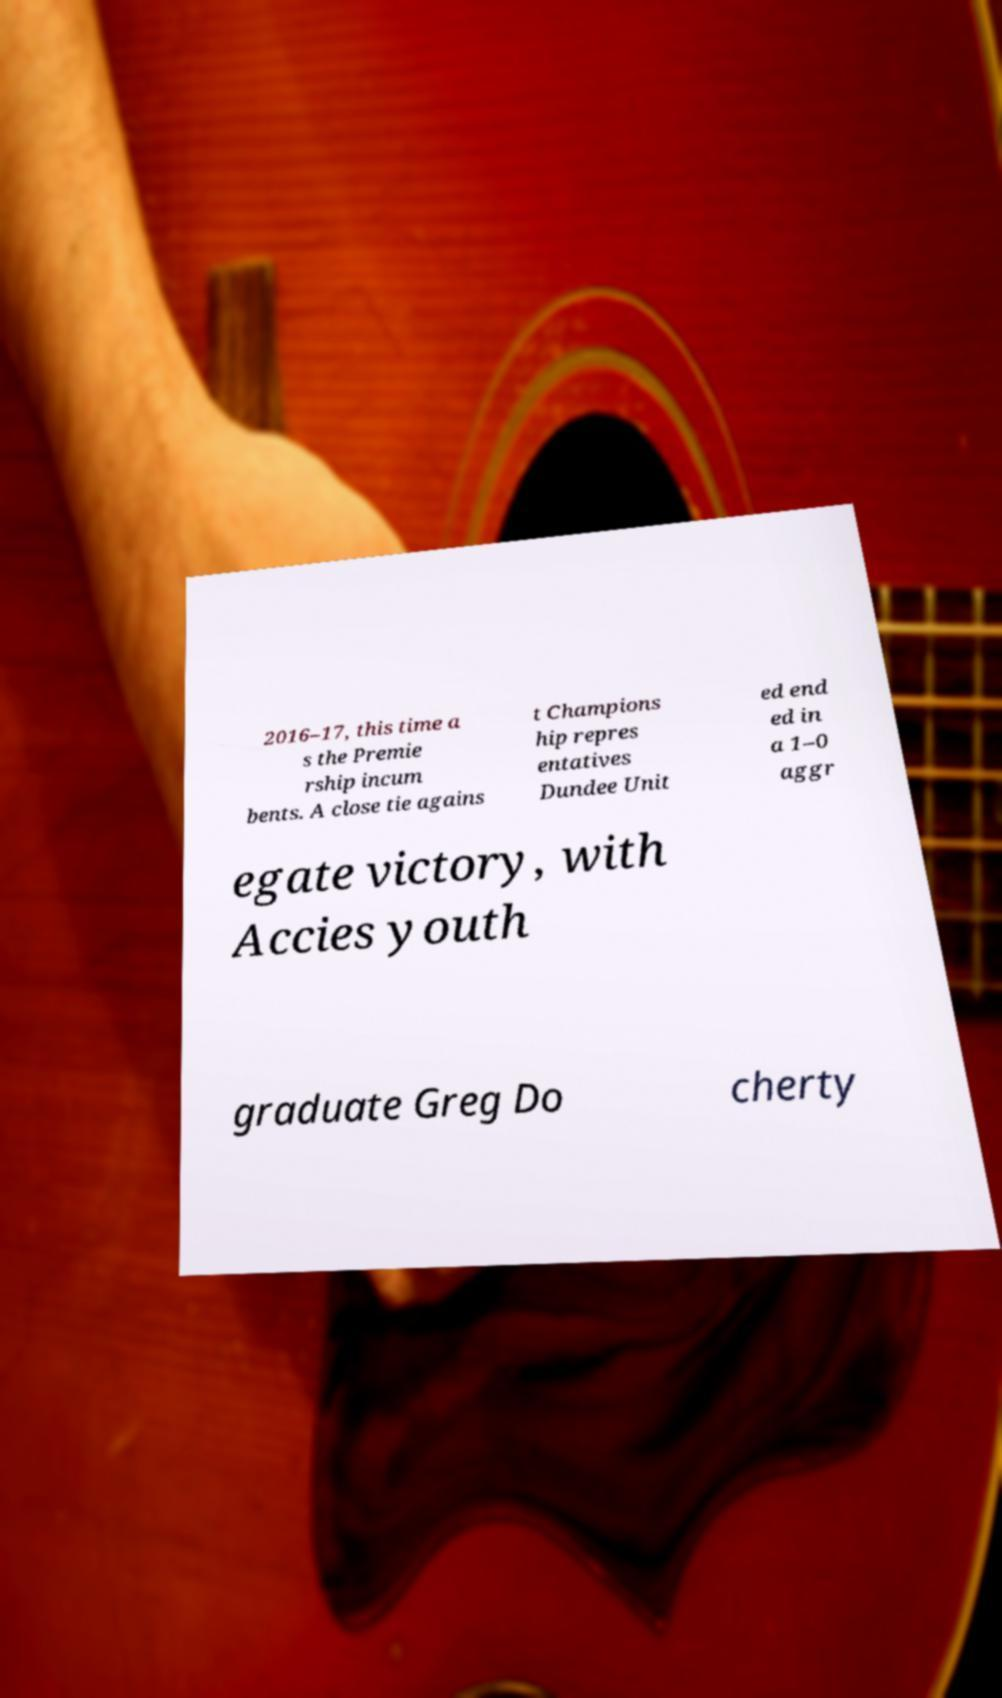For documentation purposes, I need the text within this image transcribed. Could you provide that? 2016–17, this time a s the Premie rship incum bents. A close tie agains t Champions hip repres entatives Dundee Unit ed end ed in a 1–0 aggr egate victory, with Accies youth graduate Greg Do cherty 